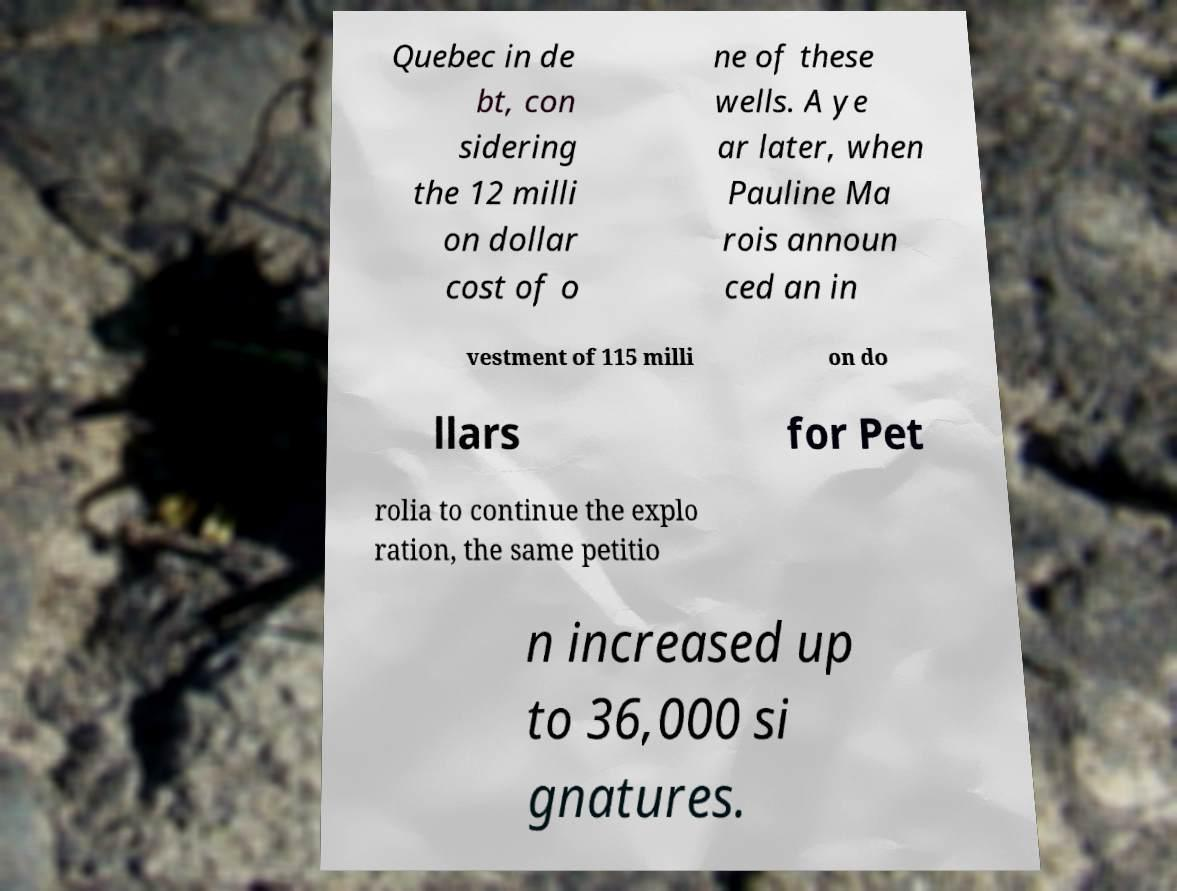Can you read and provide the text displayed in the image?This photo seems to have some interesting text. Can you extract and type it out for me? Quebec in de bt, con sidering the 12 milli on dollar cost of o ne of these wells. A ye ar later, when Pauline Ma rois announ ced an in vestment of 115 milli on do llars for Pet rolia to continue the explo ration, the same petitio n increased up to 36,000 si gnatures. 